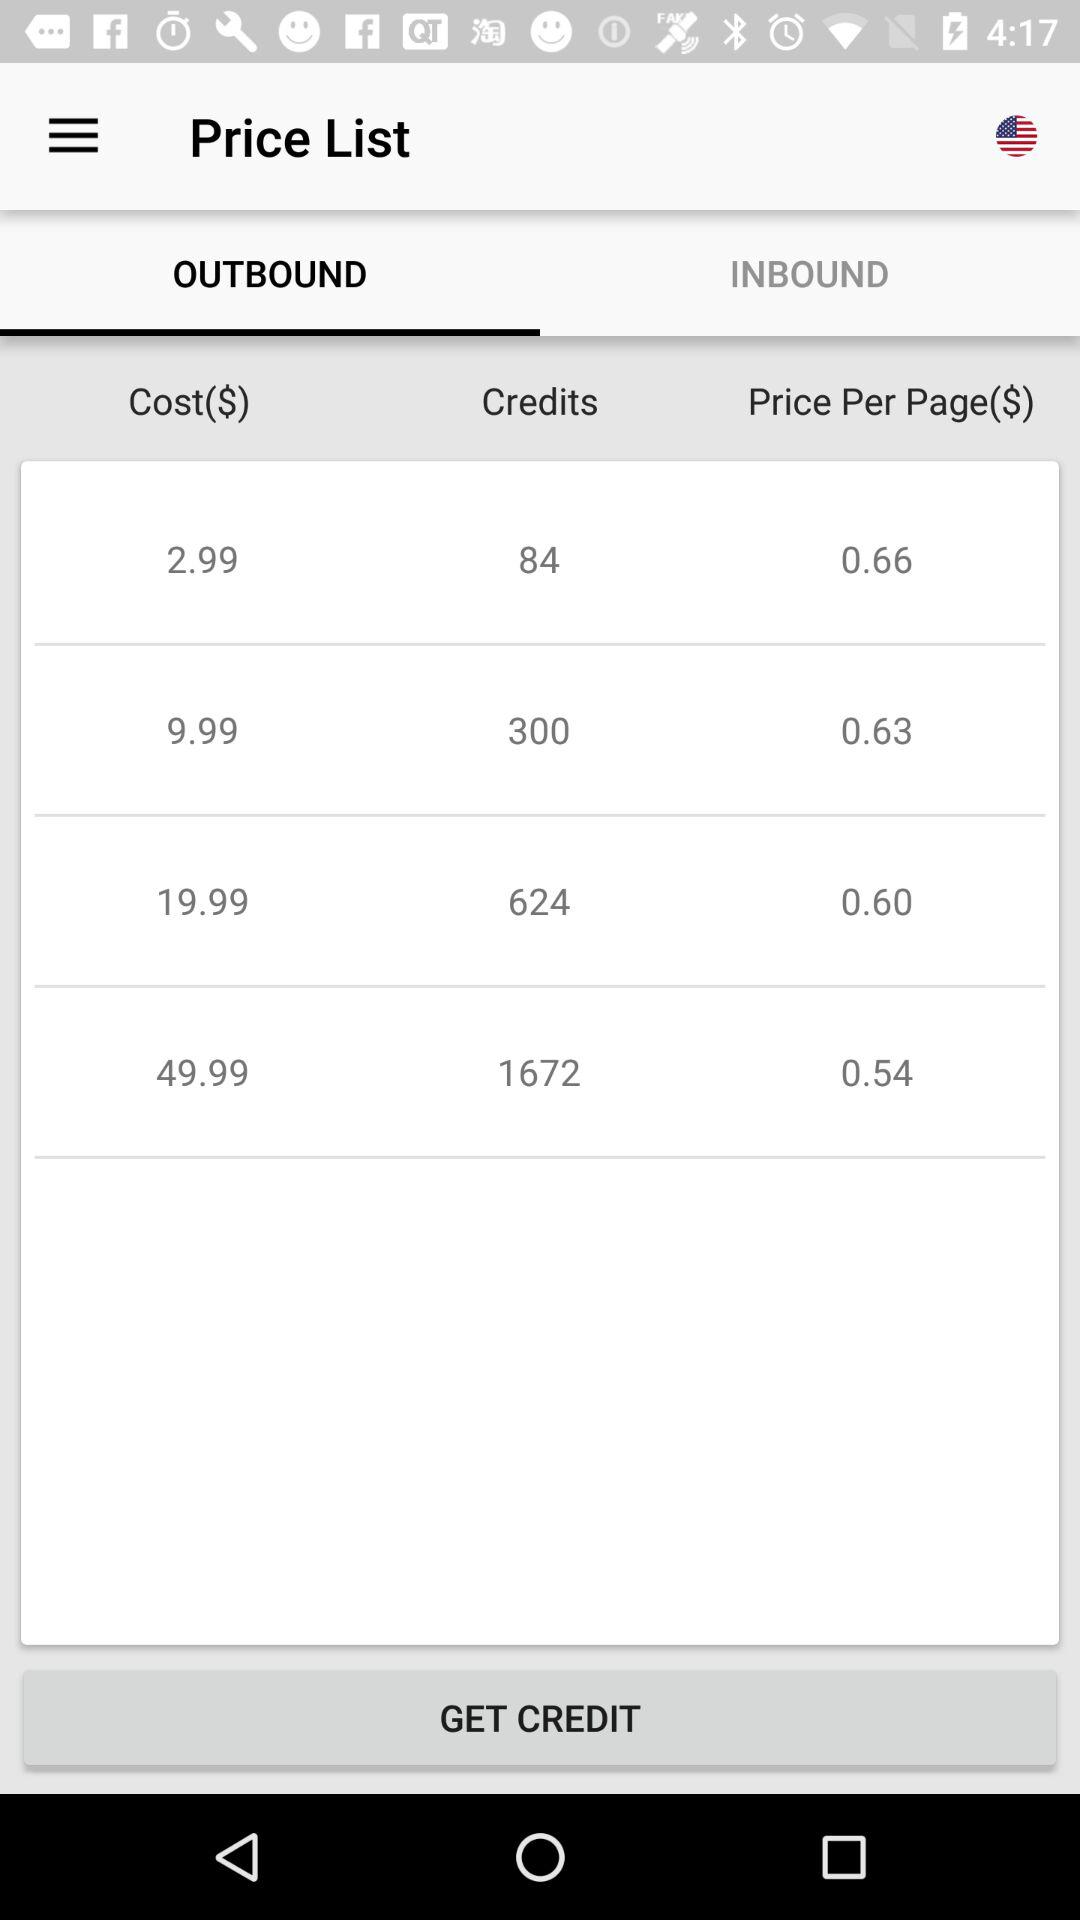Which tab is selected? The selected tab is "OUTBOUND". 